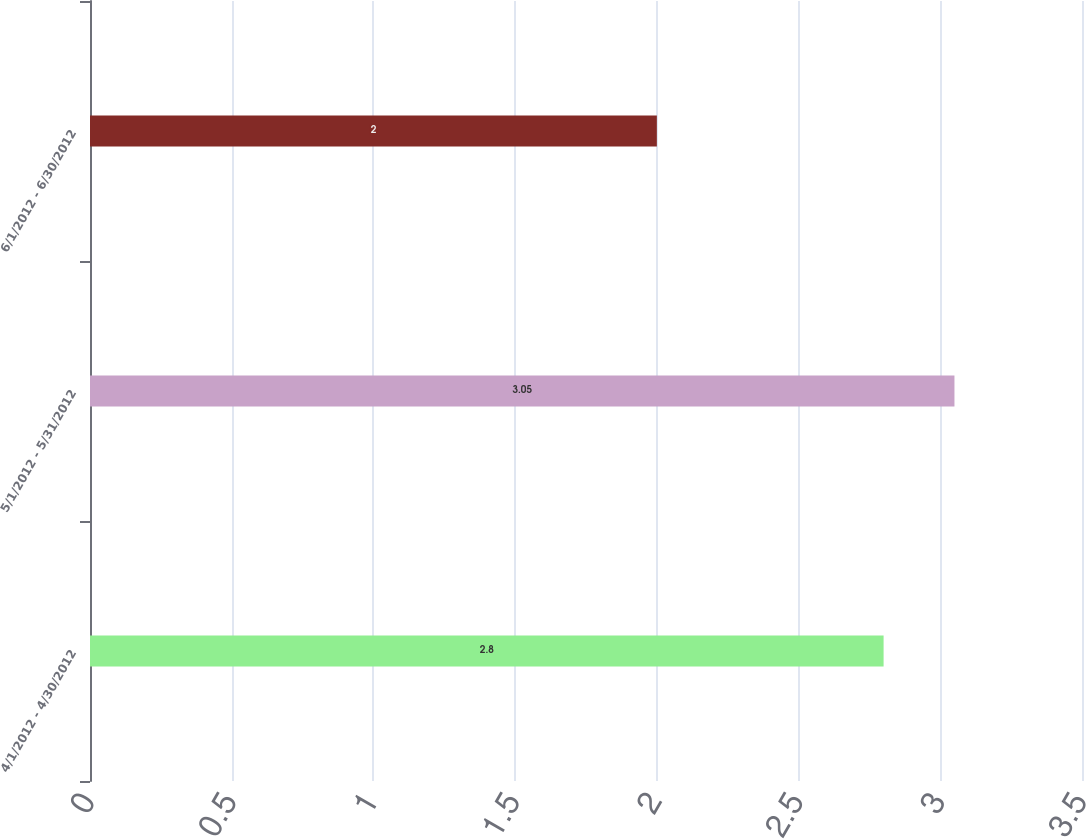Convert chart. <chart><loc_0><loc_0><loc_500><loc_500><bar_chart><fcel>4/1/2012 - 4/30/2012<fcel>5/1/2012 - 5/31/2012<fcel>6/1/2012 - 6/30/2012<nl><fcel>2.8<fcel>3.05<fcel>2<nl></chart> 